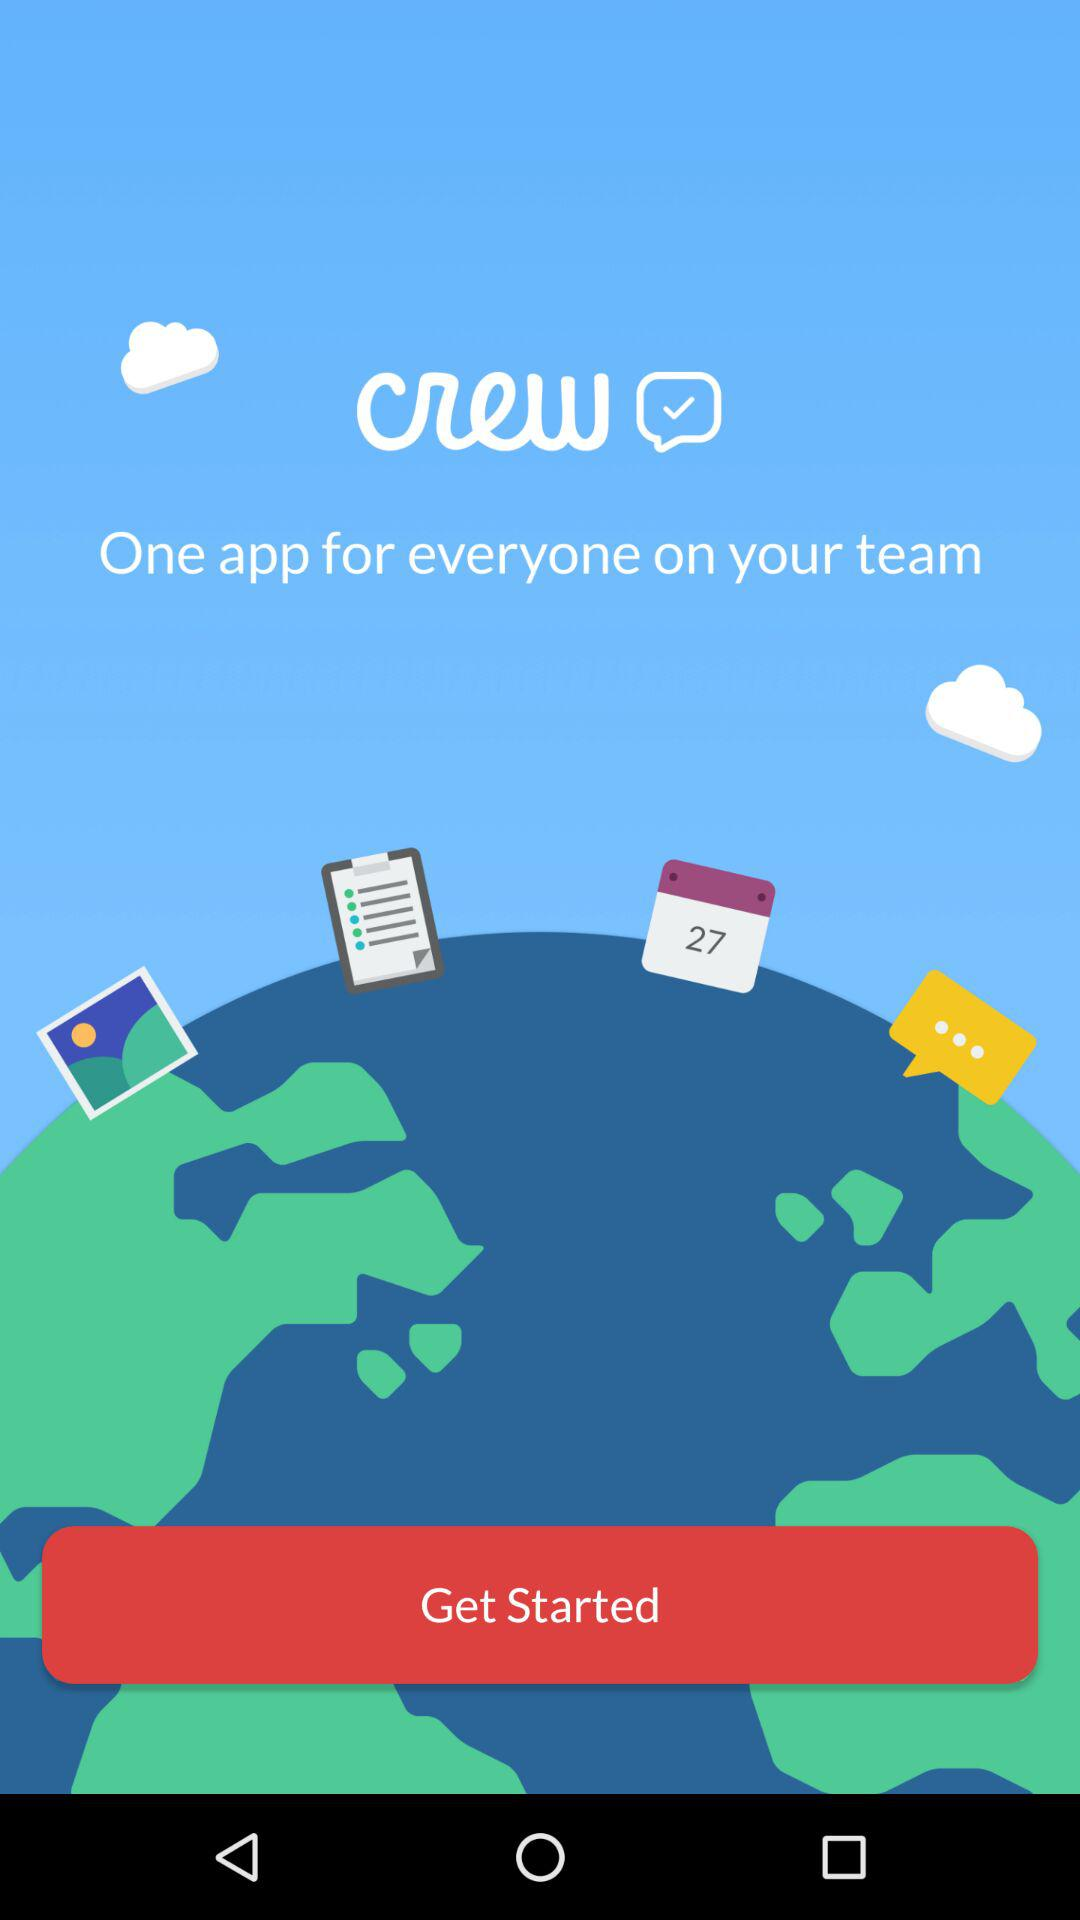How many people are on my team?
When the provided information is insufficient, respond with <no answer>. <no answer> 